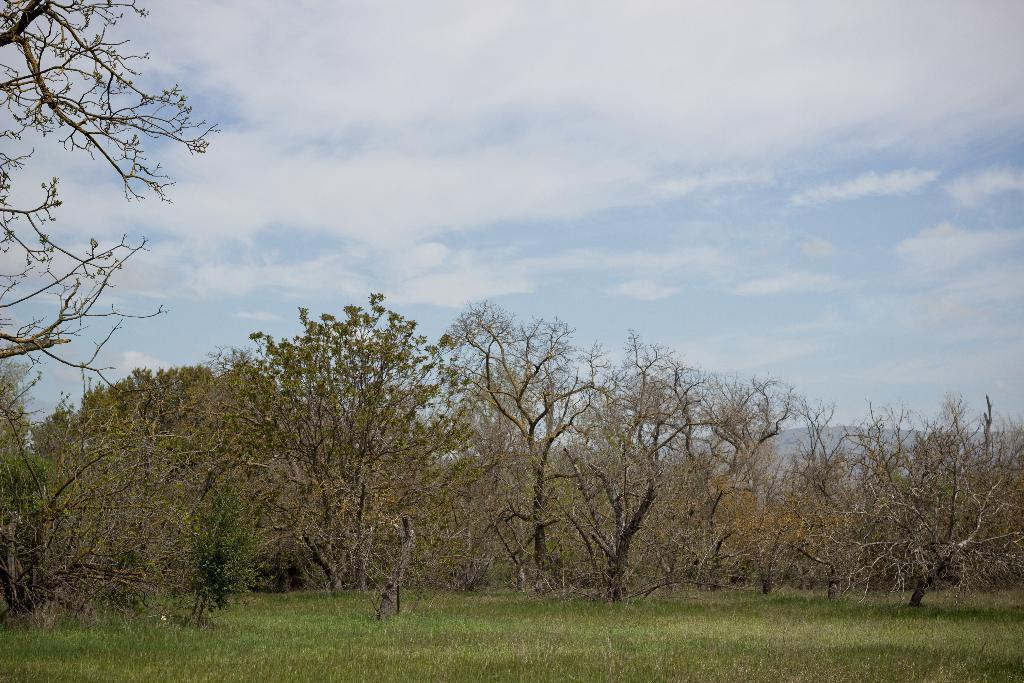What type of vegetation is present at the bottom of the image? There is grass on the ground at the bottom of the image. What other natural elements can be seen in the image? There are many trees in the image. What is visible at the top of the image? The sky is visible at the top of the image. What can be observed in the sky? Clouds are present in the sky. What type of nut is being used as a caption for the trees in the image? There is no nut or caption present in the image; it features grass, trees, and clouds in the sky. What material is the wool made of in the image? There is no wool present in the image. 